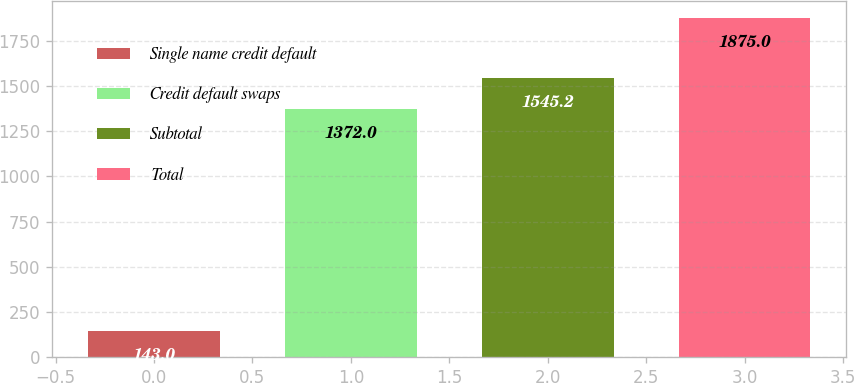Convert chart. <chart><loc_0><loc_0><loc_500><loc_500><bar_chart><fcel>Single name credit default<fcel>Credit default swaps<fcel>Subtotal<fcel>Total<nl><fcel>143<fcel>1372<fcel>1545.2<fcel>1875<nl></chart> 